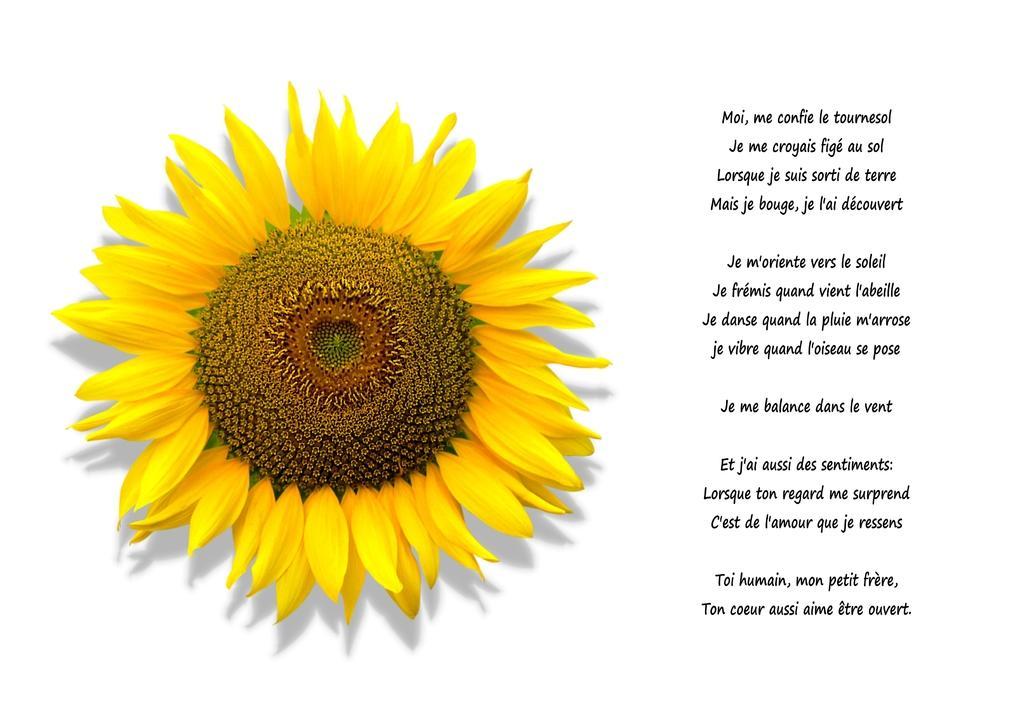Please provide a concise description of this image. Something written on this poster. Here we can see sunflower. Background it is white. 